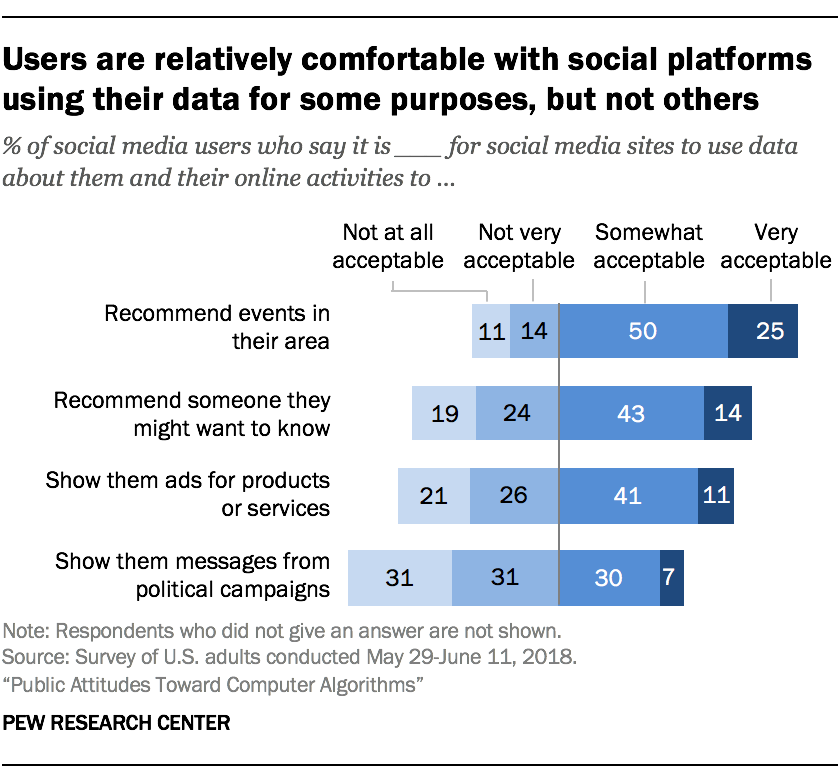Mention a couple of crucial points in this snapshot. The survey found that recommendations for events in the respondent's area received the highest rating of 'Very Acceptable' as a response to the question of what type of content would they like to receive. The results show that 0.18% more people answered Very acceptable for the most popular response compared to the least popular response. 